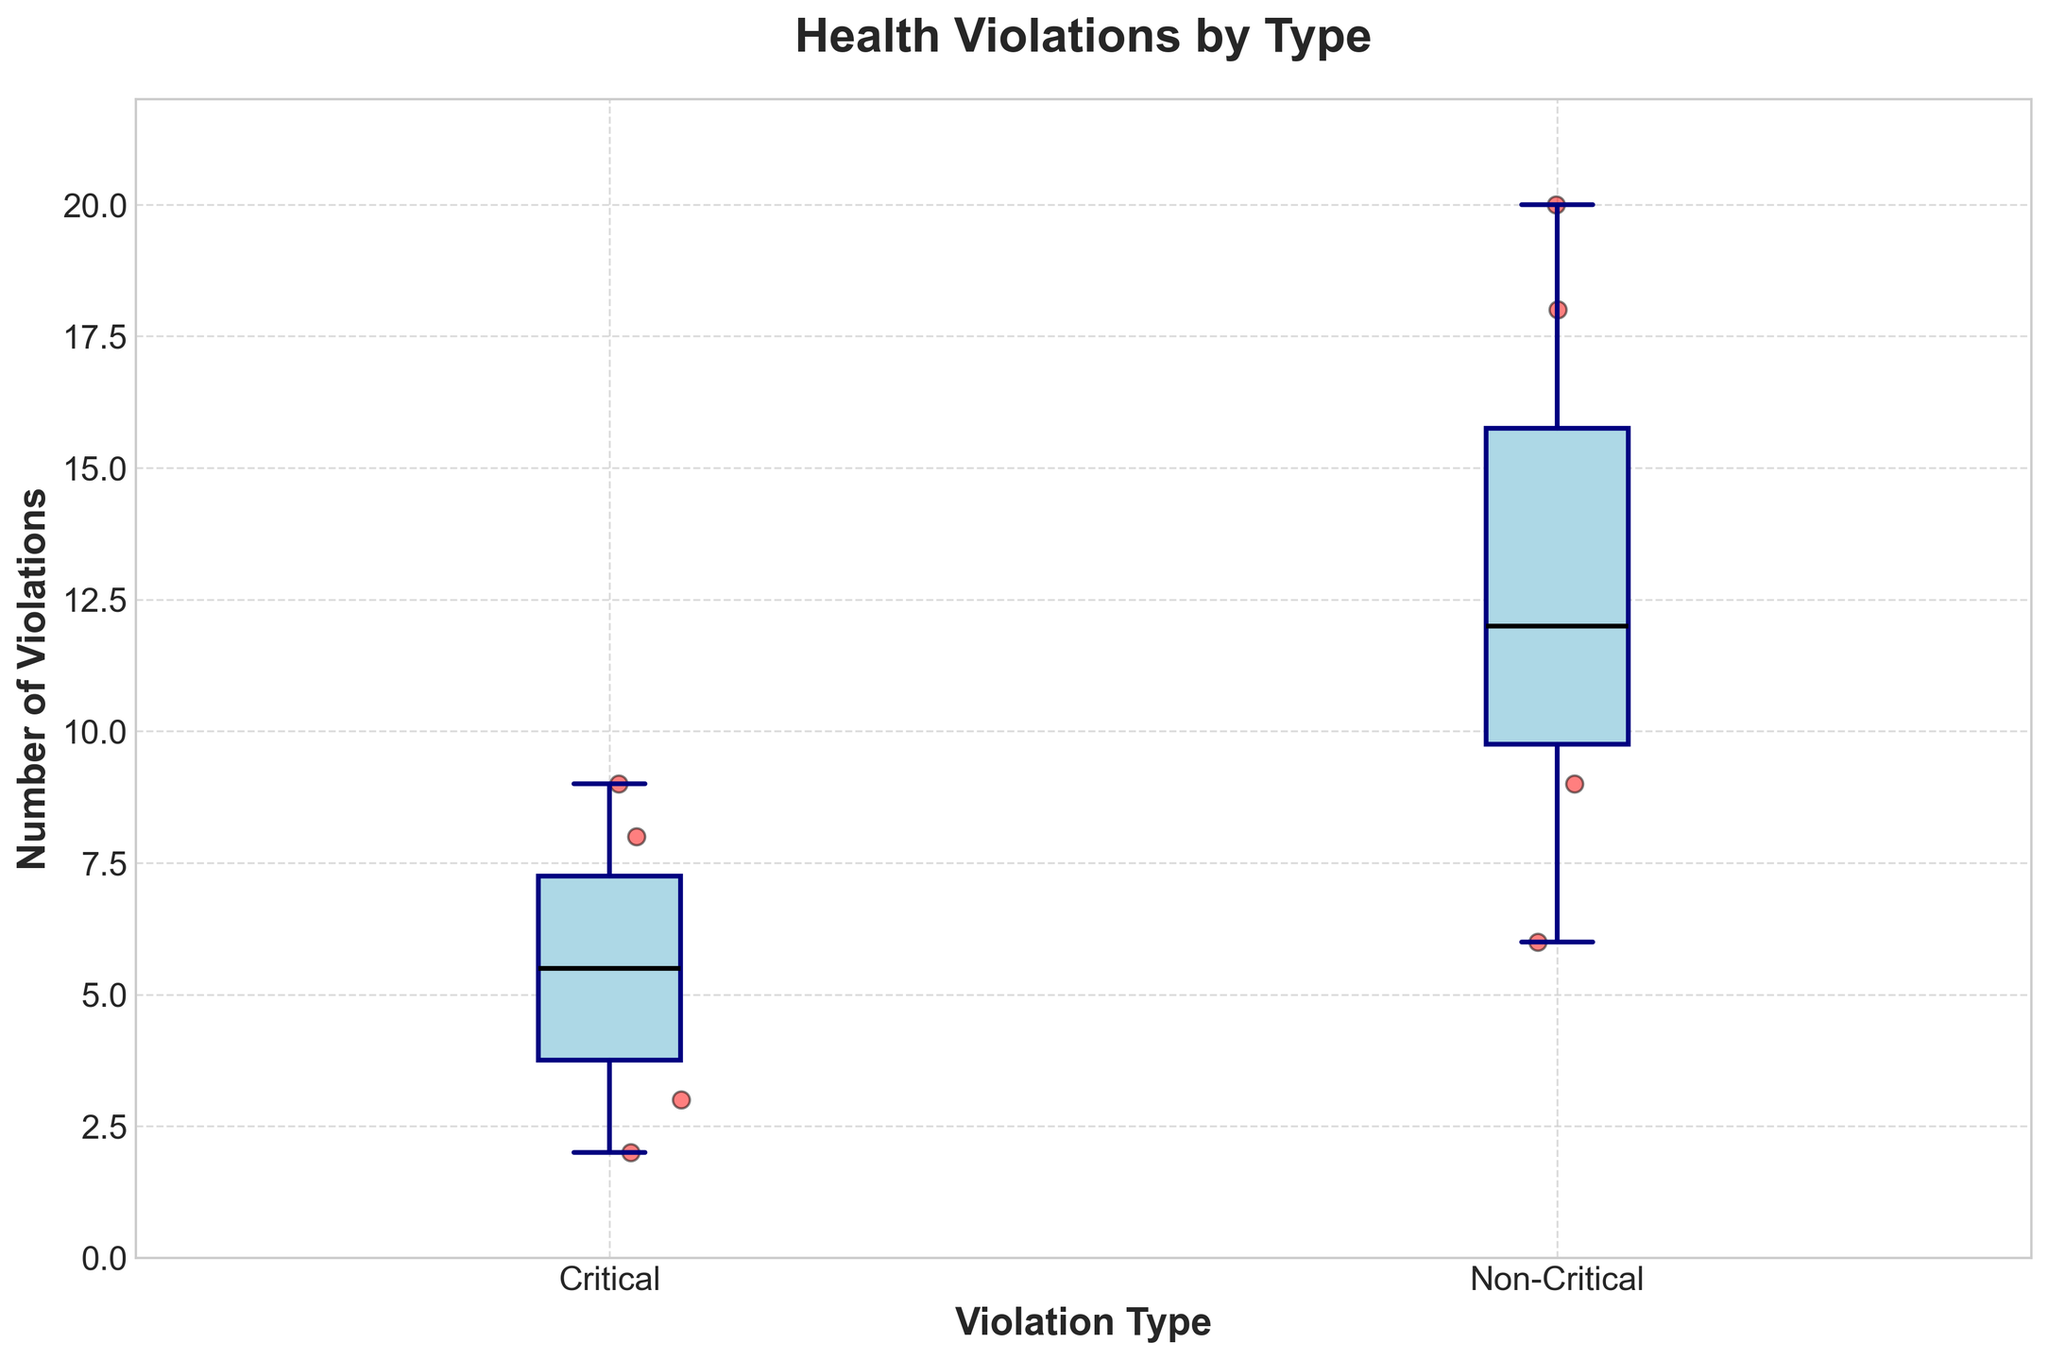What is the title of the plot? The title is prominently displayed at the top of the plot. It helps in understanding the context of the visualized data.
Answer: Health Violations by Type How many types of violations are compared in the plot? The x-axis shows labels indicating the types of violations. By counting the different labels, we can determine the number of types.
Answer: 2 Which type of violation has a higher median number of violations? The median is represented by the black line within the boxes. By comparing the heights of these lines, we can determine which type has a higher median.
Answer: Non-Critical What is the median number of Critical violations? The black line inside the "Critical" box represents the median. The y-axis helps in reading the exact value.
Answer: 5 How many data points are plotted for Non-Critical violations? The plot has dots representing individual data points. By counting the red dots in the Non-Critical group, we find the total data points.
Answer: 8 Which type of violation shows more variability in the number of violations? Variability is inferred from the spread of the box and whiskers. The larger the spread, the greater the variability.
Answer: Non-Critical What is the range of violation counts for Critical violations? The range is found by subtracting the minimum value from the maximum value within the whiskers of the Critical box.
Answer: 9 - 2 = 7 Are there any outliers in the Critical violations category? Outliers appear as individual points outside the whiskers. By examining the distribution, we can check for such points.
Answer: No What is the interquartile range (IQR) of Non-Critical violations? The IQR is the difference between the 75th percentile (top edge of the box) and the 25th percentile (bottom edge of the box) values.
Answer: (Maximum value of lower quartile - Minimum value of upper quartile) Which type of violation typically has more counts, based on the plot? By visually comparing the distribution and position of the boxes, we can infer which group generally has higher values.
Answer: Non-Critical 